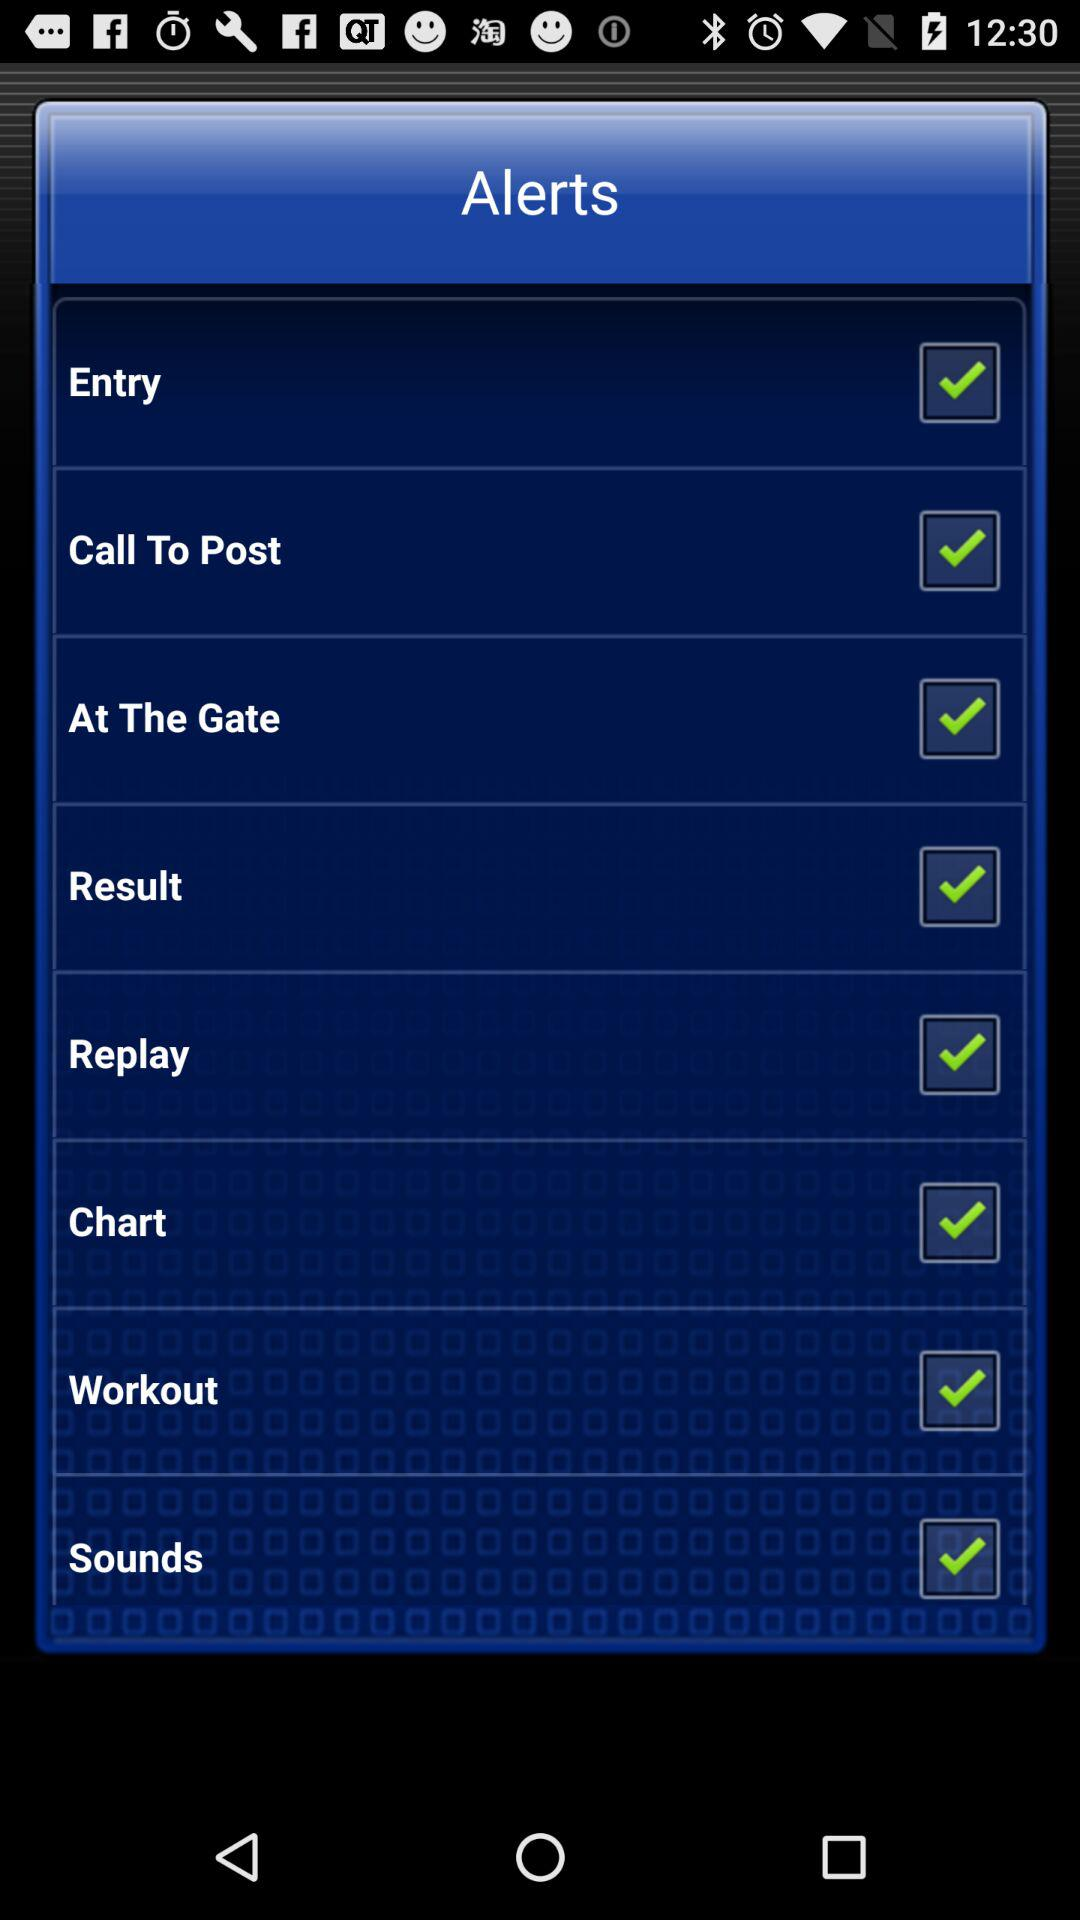Which checkbox is checked? The checked checkboxes are "Entry", "Call To Post", "At The Gate", "Result", "Replay", "Chart", "Workout" and "Sounds". 